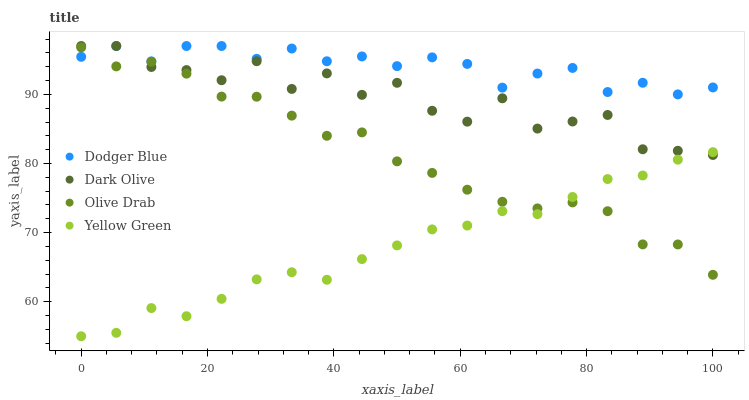Does Yellow Green have the minimum area under the curve?
Answer yes or no. Yes. Does Dodger Blue have the maximum area under the curve?
Answer yes or no. Yes. Does Dodger Blue have the minimum area under the curve?
Answer yes or no. No. Does Yellow Green have the maximum area under the curve?
Answer yes or no. No. Is Yellow Green the smoothest?
Answer yes or no. Yes. Is Dark Olive the roughest?
Answer yes or no. Yes. Is Dodger Blue the smoothest?
Answer yes or no. No. Is Dodger Blue the roughest?
Answer yes or no. No. Does Yellow Green have the lowest value?
Answer yes or no. Yes. Does Dodger Blue have the lowest value?
Answer yes or no. No. Does Dodger Blue have the highest value?
Answer yes or no. Yes. Does Yellow Green have the highest value?
Answer yes or no. No. Is Yellow Green less than Dodger Blue?
Answer yes or no. Yes. Is Dodger Blue greater than Yellow Green?
Answer yes or no. Yes. Does Olive Drab intersect Dodger Blue?
Answer yes or no. Yes. Is Olive Drab less than Dodger Blue?
Answer yes or no. No. Is Olive Drab greater than Dodger Blue?
Answer yes or no. No. Does Yellow Green intersect Dodger Blue?
Answer yes or no. No. 